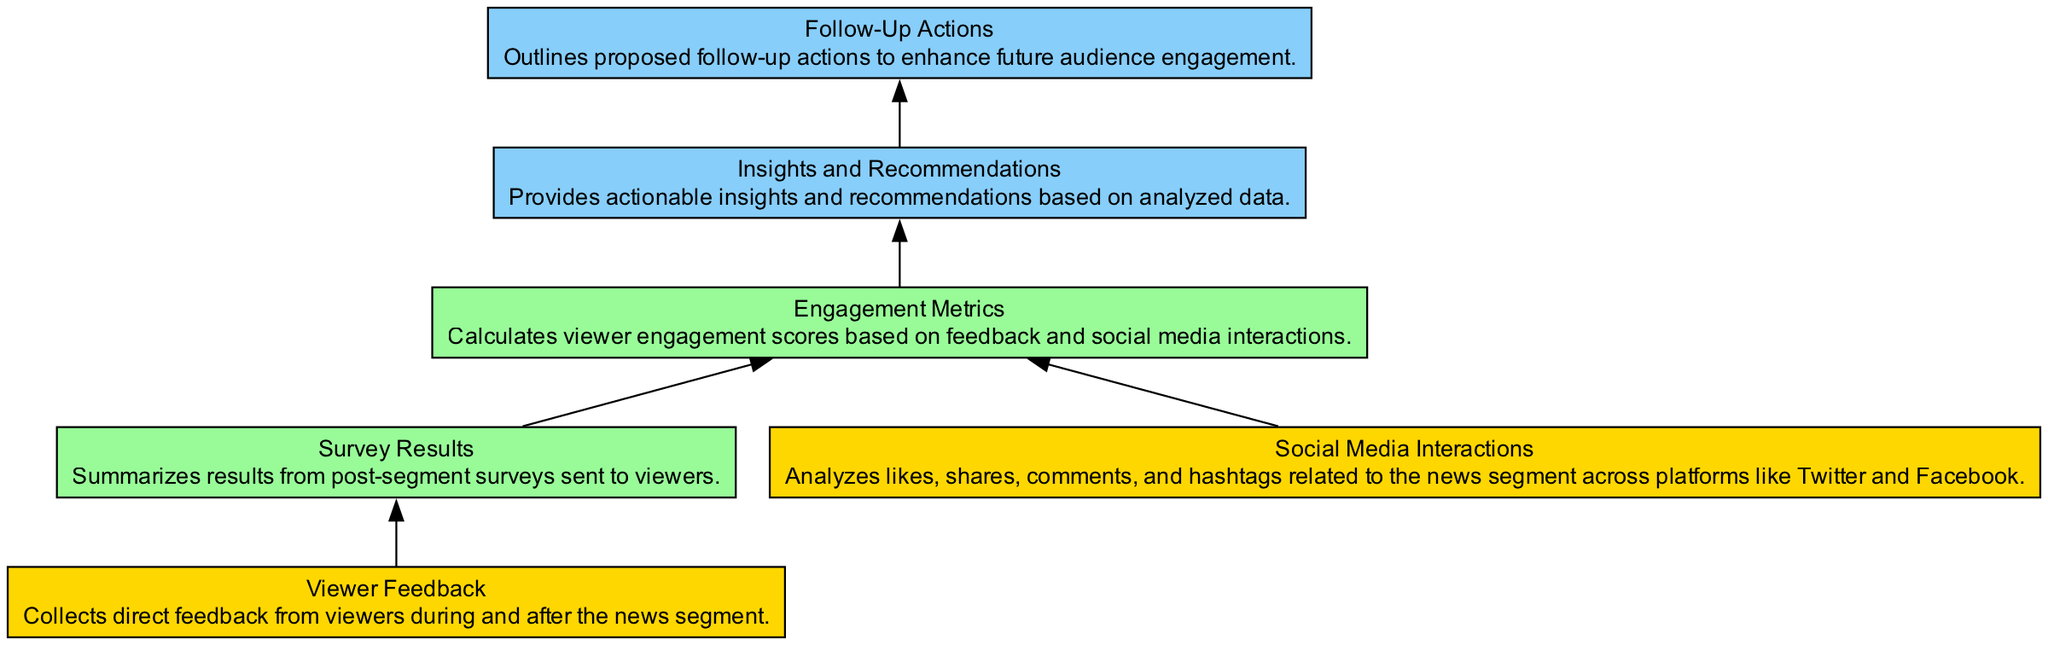What is the first node in this diagram? The first node is "Viewer Feedback," which is the starting point of the flow chart.
Answer: Viewer Feedback How many process nodes are in the diagram? There are two process nodes: "Survey Results" and "Engagement Metrics."
Answer: Two What connects the "Social Media Interactions" node to the "Engagement Metrics" node? The flow chart shows an edge that connects "Social Media Interactions" directly to "Engagement Metrics."
Answer: An edge What is the output of the process that follows "Insights"? The output is "Follow-Up Actions," which is the next node after the insights are derived.
Answer: Follow-Up Actions Which two nodes feed into "Engagement Metrics"? The nodes "Survey Results" and "Social Media Interactions" both connect to "Engagement Metrics," indicating they provide input for calculating engagement scores.
Answer: Survey Results and Social Media Interactions What element type is "Insights"? "Insights" is categorized as an output type in the diagram.
Answer: Output What type of feedback is collected in the first node? The first node collects "Viewer Feedback" which directly captures responses from the audience.
Answer: Viewer Feedback How does feedback influence the analysis flow in the diagram? Feedback influences the analysis by being an input to the "Survey Results" and contributing to the calculation of "Engagement Metrics."
Answer: Influences Engagement Metrics What is the final outcome of the analysis? The final outcome is "Follow-Up Actions," which outlines actions based on the insights generated from the analysis.
Answer: Follow-Up Actions 